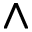<formula> <loc_0><loc_0><loc_500><loc_500>\wedge</formula> 